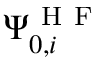<formula> <loc_0><loc_0><loc_500><loc_500>\Psi _ { 0 , i } ^ { H F }</formula> 